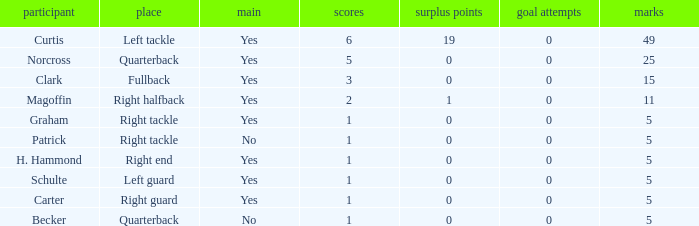Name the extra points for left guard 0.0. 